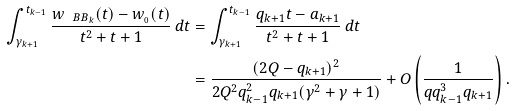<formula> <loc_0><loc_0><loc_500><loc_500>\int _ { \gamma _ { k + 1 } } ^ { t _ { k - 1 } } \frac { w _ { \ B B _ { k } } ( t ) - w _ { \AA _ { 0 } } ( t ) } { t ^ { 2 } + t + 1 } \, d t & = \int _ { \gamma _ { k + 1 } } ^ { t _ { k - 1 } } \frac { q _ { k + 1 } t - a _ { k + 1 } } { t ^ { 2 } + t + 1 } \, d t \\ & = \frac { ( 2 Q - q _ { k + 1 } ) ^ { 2 } } { 2 Q ^ { 2 } q _ { k - 1 } ^ { 2 } q _ { k + 1 } ( \gamma ^ { 2 } + \gamma + 1 ) } + O \left ( \frac { 1 } { q q _ { k - 1 } ^ { 3 } q _ { k + 1 } } \right ) .</formula> 